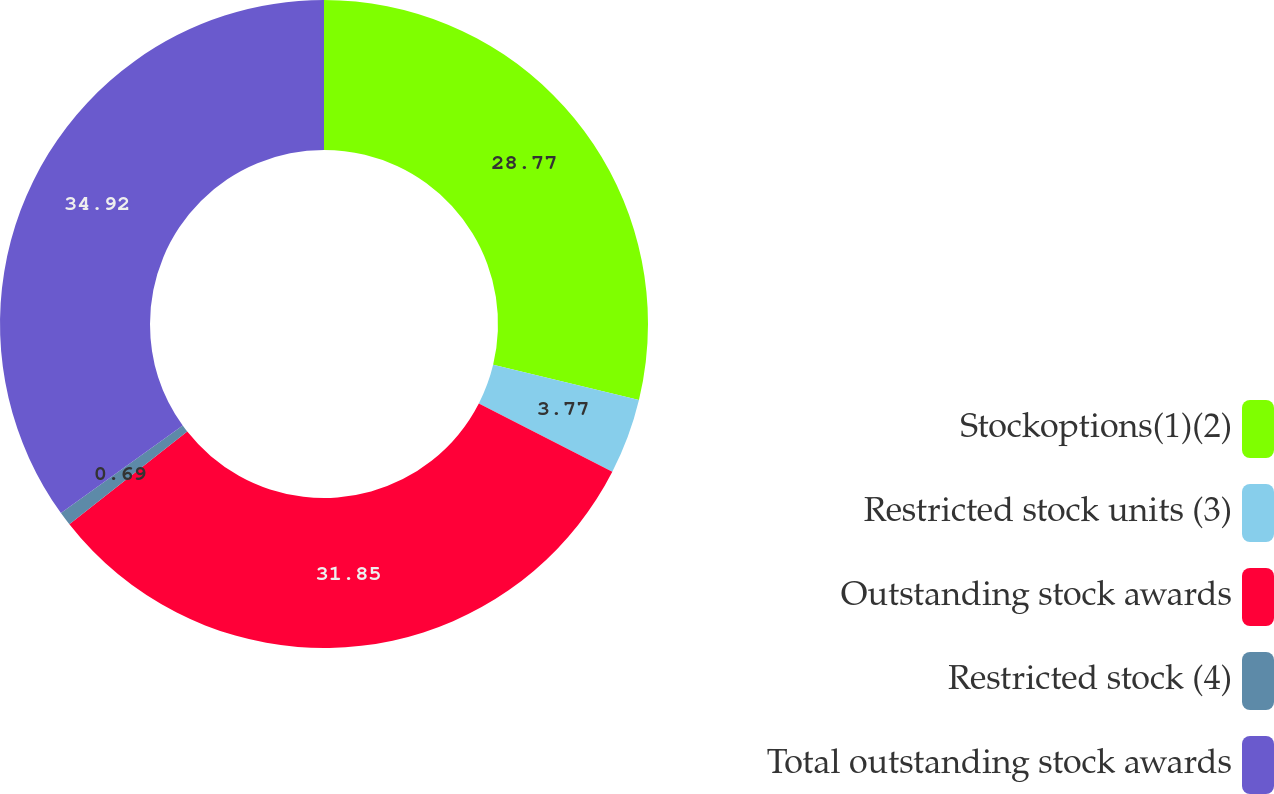Convert chart to OTSL. <chart><loc_0><loc_0><loc_500><loc_500><pie_chart><fcel>Stockoptions(1)(2)<fcel>Restricted stock units (3)<fcel>Outstanding stock awards<fcel>Restricted stock (4)<fcel>Total outstanding stock awards<nl><fcel>28.77%<fcel>3.77%<fcel>31.85%<fcel>0.69%<fcel>34.92%<nl></chart> 